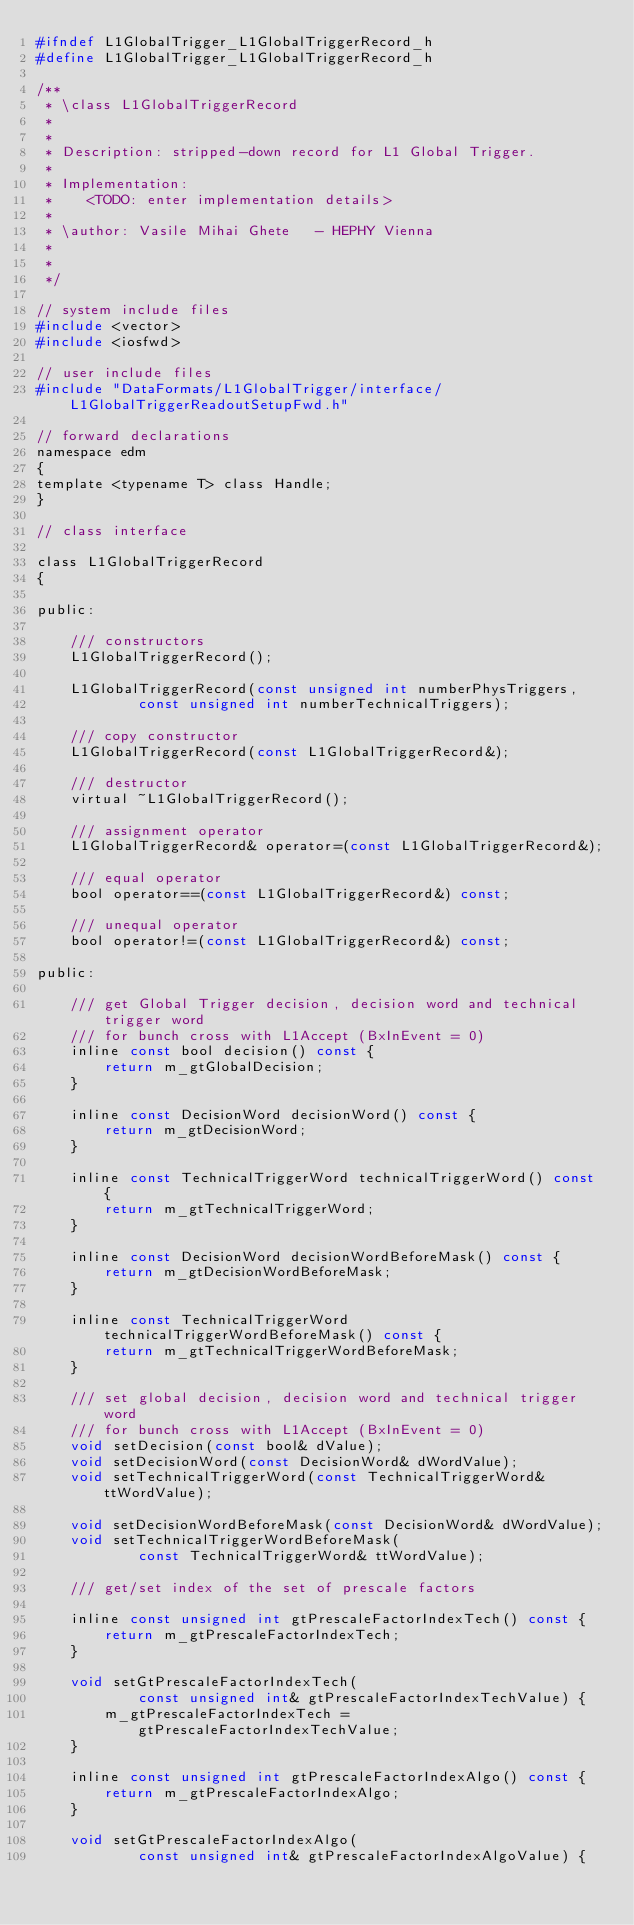Convert code to text. <code><loc_0><loc_0><loc_500><loc_500><_C_>#ifndef L1GlobalTrigger_L1GlobalTriggerRecord_h
#define L1GlobalTrigger_L1GlobalTriggerRecord_h

/**
 * \class L1GlobalTriggerRecord
 * 
 * 
 * Description: stripped-down record for L1 Global Trigger.  
 *
 * Implementation:
 *    <TODO: enter implementation details>
 *   
 * \author: Vasile Mihai Ghete   - HEPHY Vienna
 * 
 *
 */

// system include files
#include <vector>
#include <iosfwd>

// user include files
#include "DataFormats/L1GlobalTrigger/interface/L1GlobalTriggerReadoutSetupFwd.h"

// forward declarations
namespace edm
{
template <typename T> class Handle;
}

// class interface

class L1GlobalTriggerRecord
{

public:

    /// constructors
    L1GlobalTriggerRecord();

    L1GlobalTriggerRecord(const unsigned int numberPhysTriggers,
            const unsigned int numberTechnicalTriggers);

    /// copy constructor
    L1GlobalTriggerRecord(const L1GlobalTriggerRecord&);

    /// destructor
    virtual ~L1GlobalTriggerRecord();

    /// assignment operator
    L1GlobalTriggerRecord& operator=(const L1GlobalTriggerRecord&);

    /// equal operator
    bool operator==(const L1GlobalTriggerRecord&) const;

    /// unequal operator
    bool operator!=(const L1GlobalTriggerRecord&) const;

public:

    /// get Global Trigger decision, decision word and technical trigger word
    /// for bunch cross with L1Accept (BxInEvent = 0) 
    inline const bool decision() const {
        return m_gtGlobalDecision;
    }

    inline const DecisionWord decisionWord() const {
        return m_gtDecisionWord;
    }

    inline const TechnicalTriggerWord technicalTriggerWord() const {
        return m_gtTechnicalTriggerWord;
    }

    inline const DecisionWord decisionWordBeforeMask() const {
        return m_gtDecisionWordBeforeMask;
    }

    inline const TechnicalTriggerWord technicalTriggerWordBeforeMask() const {
        return m_gtTechnicalTriggerWordBeforeMask;
    }

    /// set global decision, decision word and technical trigger word
    /// for bunch cross with L1Accept (BxInEvent = 0) 
    void setDecision(const bool& dValue);
    void setDecisionWord(const DecisionWord& dWordValue);
    void setTechnicalTriggerWord(const TechnicalTriggerWord& ttWordValue);

    void setDecisionWordBeforeMask(const DecisionWord& dWordValue);
    void setTechnicalTriggerWordBeforeMask(
            const TechnicalTriggerWord& ttWordValue);

    /// get/set index of the set of prescale factors

    inline const unsigned int gtPrescaleFactorIndexTech() const {
        return m_gtPrescaleFactorIndexTech;
    }

    void setGtPrescaleFactorIndexTech(
            const unsigned int& gtPrescaleFactorIndexTechValue) {
        m_gtPrescaleFactorIndexTech = gtPrescaleFactorIndexTechValue;
    }

    inline const unsigned int gtPrescaleFactorIndexAlgo() const {
        return m_gtPrescaleFactorIndexAlgo;
    }

    void setGtPrescaleFactorIndexAlgo(
            const unsigned int& gtPrescaleFactorIndexAlgoValue) {</code> 